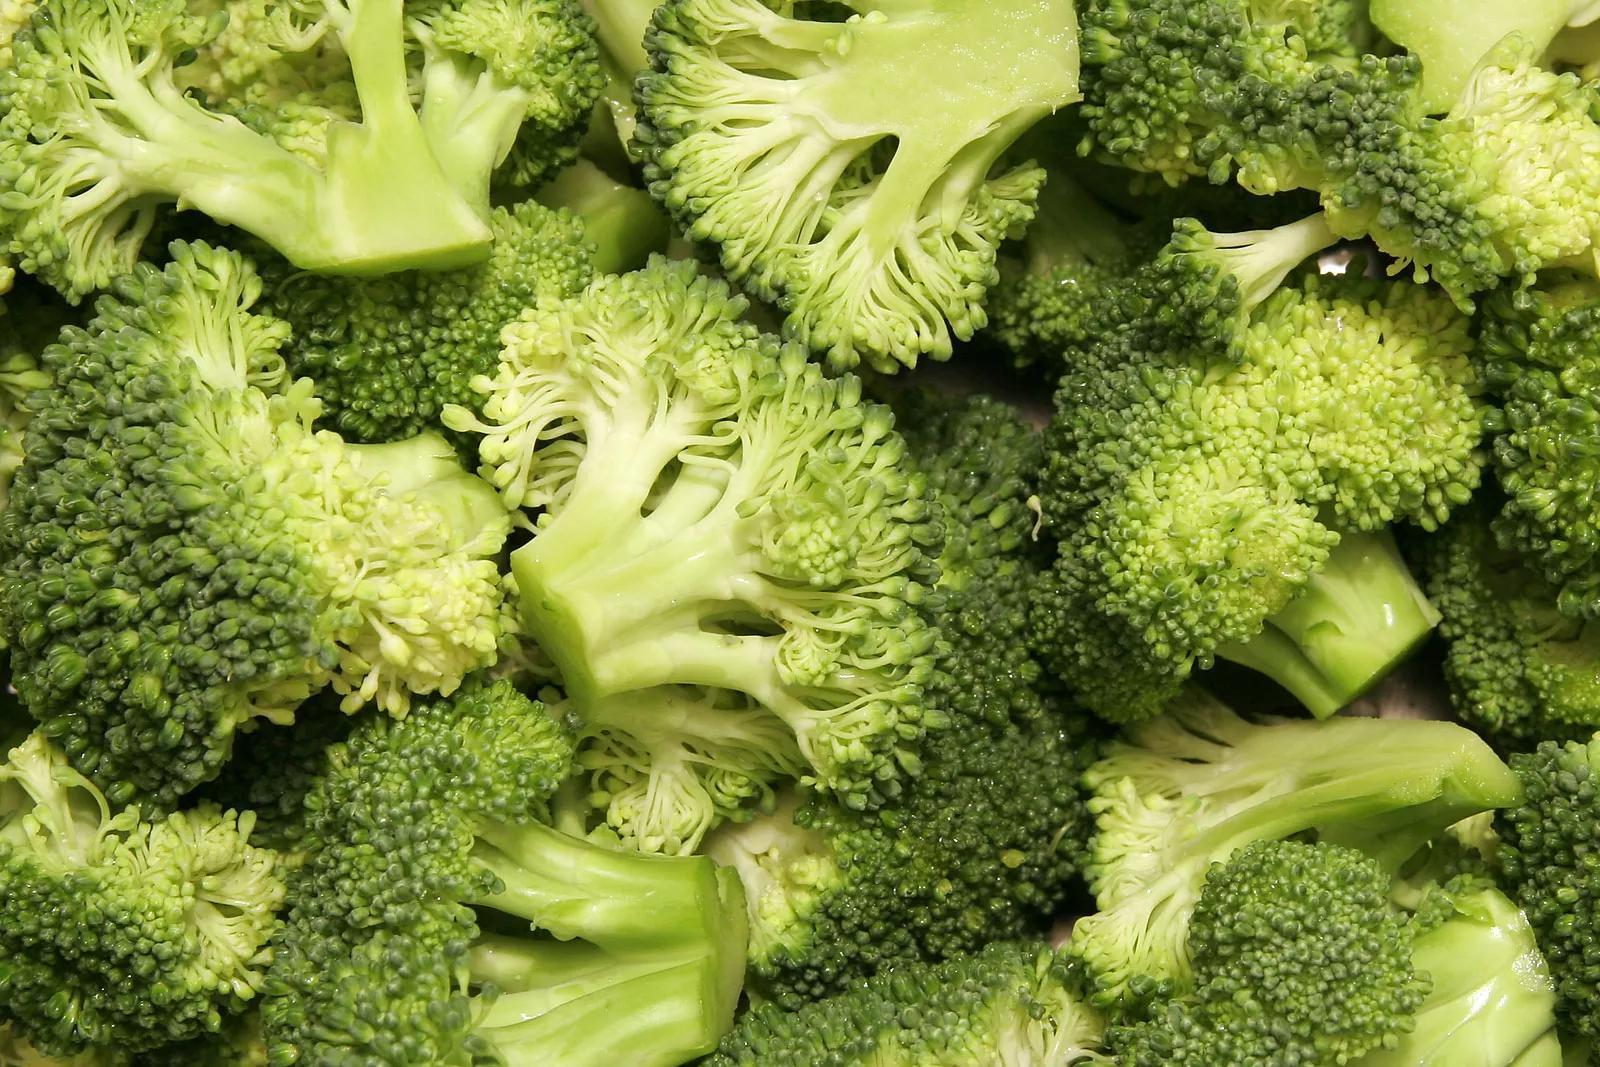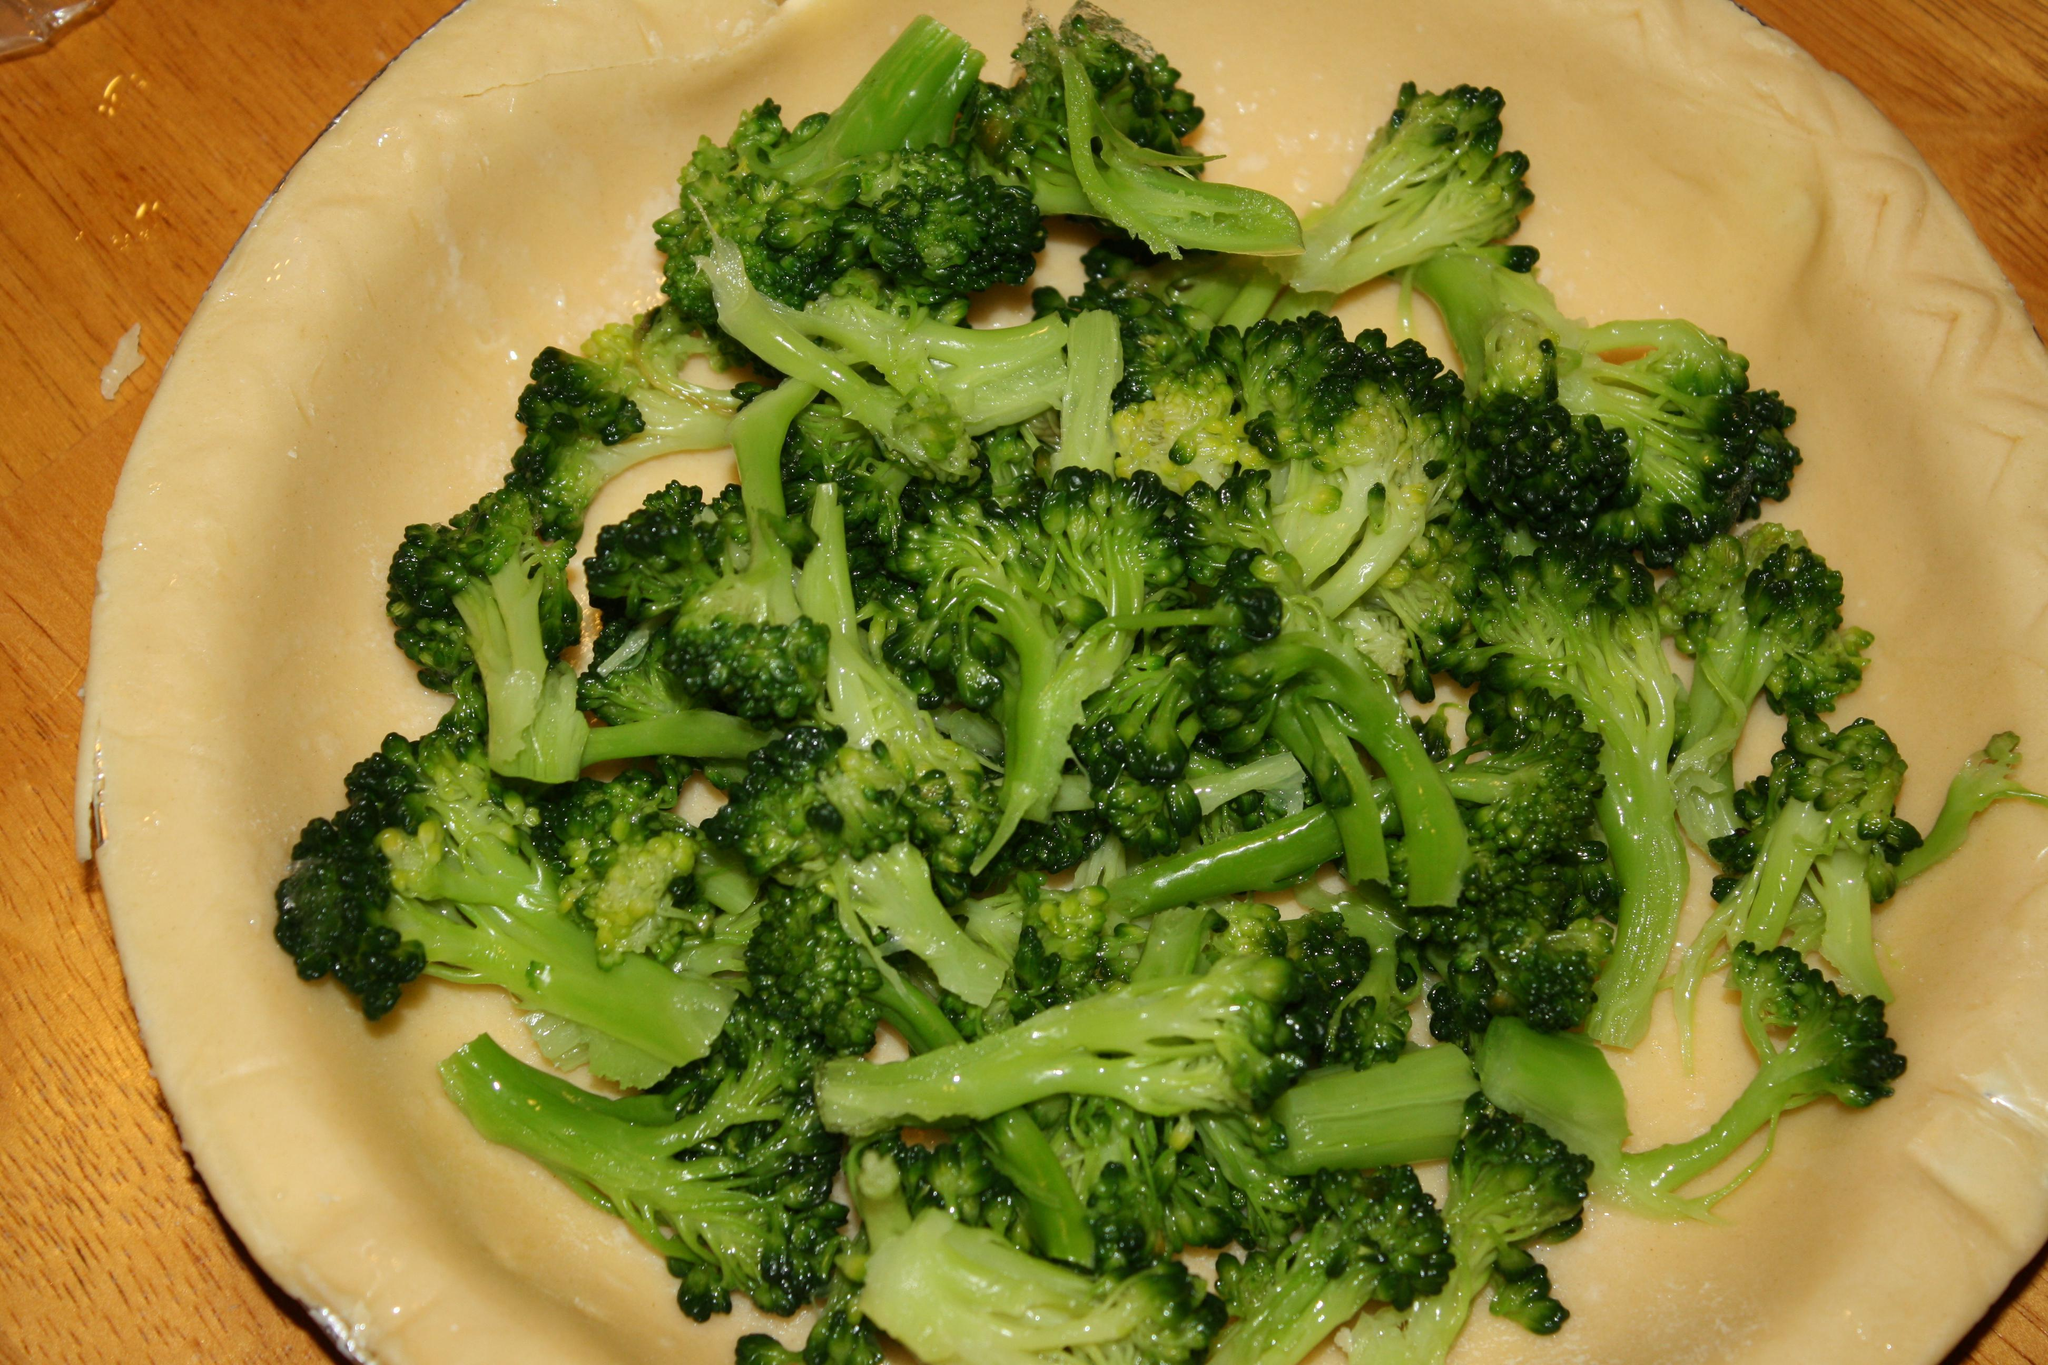The first image is the image on the left, the second image is the image on the right. Given the left and right images, does the statement "An image shows broccoli in a white container with a handle." hold true? Answer yes or no. No. The first image is the image on the left, the second image is the image on the right. Examine the images to the left and right. Is the description "No dish is visible in the left image." accurate? Answer yes or no. Yes. 